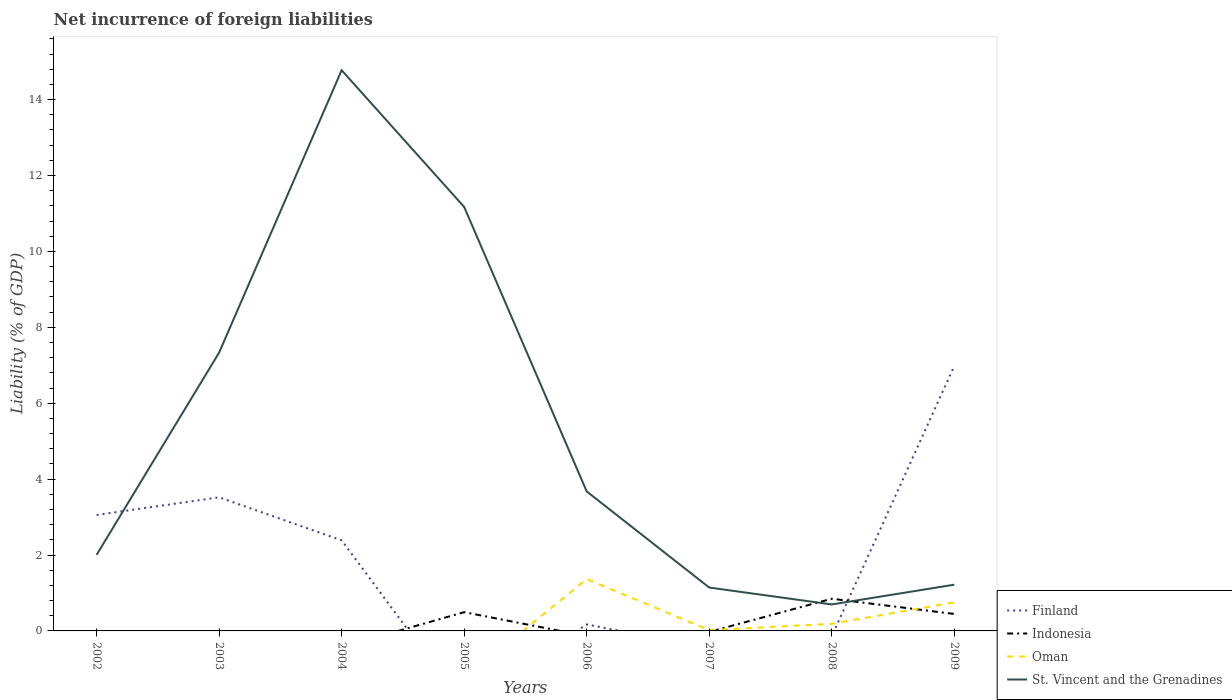Does the line corresponding to Indonesia intersect with the line corresponding to Oman?
Your answer should be very brief. Yes. Is the number of lines equal to the number of legend labels?
Your answer should be very brief. No. What is the total net incurrence of foreign liabilities in St. Vincent and the Grenadines in the graph?
Give a very brief answer. -3.84. What is the difference between the highest and the second highest net incurrence of foreign liabilities in St. Vincent and the Grenadines?
Keep it short and to the point. 14.08. What is the difference between the highest and the lowest net incurrence of foreign liabilities in St. Vincent and the Grenadines?
Your response must be concise. 3. Is the net incurrence of foreign liabilities in Indonesia strictly greater than the net incurrence of foreign liabilities in St. Vincent and the Grenadines over the years?
Ensure brevity in your answer.  No. How many lines are there?
Give a very brief answer. 4. How many years are there in the graph?
Keep it short and to the point. 8. What is the difference between two consecutive major ticks on the Y-axis?
Ensure brevity in your answer.  2. Are the values on the major ticks of Y-axis written in scientific E-notation?
Your answer should be very brief. No. Does the graph contain any zero values?
Offer a terse response. Yes. How many legend labels are there?
Your answer should be very brief. 4. What is the title of the graph?
Ensure brevity in your answer.  Net incurrence of foreign liabilities. What is the label or title of the X-axis?
Provide a succinct answer. Years. What is the label or title of the Y-axis?
Your answer should be compact. Liability (% of GDP). What is the Liability (% of GDP) of Finland in 2002?
Your response must be concise. 3.05. What is the Liability (% of GDP) of Indonesia in 2002?
Your answer should be very brief. 0. What is the Liability (% of GDP) in Oman in 2002?
Ensure brevity in your answer.  0. What is the Liability (% of GDP) in St. Vincent and the Grenadines in 2002?
Your answer should be very brief. 2. What is the Liability (% of GDP) of Finland in 2003?
Offer a terse response. 3.52. What is the Liability (% of GDP) in Indonesia in 2003?
Offer a terse response. 0. What is the Liability (% of GDP) of St. Vincent and the Grenadines in 2003?
Your response must be concise. 7.33. What is the Liability (% of GDP) of Finland in 2004?
Make the answer very short. 2.39. What is the Liability (% of GDP) of Indonesia in 2004?
Give a very brief answer. 0. What is the Liability (% of GDP) of St. Vincent and the Grenadines in 2004?
Ensure brevity in your answer.  14.77. What is the Liability (% of GDP) of Indonesia in 2005?
Provide a succinct answer. 0.49. What is the Liability (% of GDP) of St. Vincent and the Grenadines in 2005?
Your answer should be compact. 11.17. What is the Liability (% of GDP) in Finland in 2006?
Provide a short and direct response. 0.17. What is the Liability (% of GDP) of Indonesia in 2006?
Give a very brief answer. 0. What is the Liability (% of GDP) in Oman in 2006?
Offer a terse response. 1.37. What is the Liability (% of GDP) in St. Vincent and the Grenadines in 2006?
Your answer should be very brief. 3.67. What is the Liability (% of GDP) in Finland in 2007?
Offer a very short reply. 0. What is the Liability (% of GDP) of Oman in 2007?
Your answer should be very brief. 0.02. What is the Liability (% of GDP) of St. Vincent and the Grenadines in 2007?
Offer a terse response. 1.14. What is the Liability (% of GDP) in Finland in 2008?
Offer a terse response. 0. What is the Liability (% of GDP) of Indonesia in 2008?
Your response must be concise. 0.85. What is the Liability (% of GDP) of Oman in 2008?
Keep it short and to the point. 0.19. What is the Liability (% of GDP) of St. Vincent and the Grenadines in 2008?
Offer a very short reply. 0.7. What is the Liability (% of GDP) of Finland in 2009?
Give a very brief answer. 6.98. What is the Liability (% of GDP) in Indonesia in 2009?
Your response must be concise. 0.45. What is the Liability (% of GDP) in Oman in 2009?
Keep it short and to the point. 0.75. What is the Liability (% of GDP) of St. Vincent and the Grenadines in 2009?
Your answer should be very brief. 1.22. Across all years, what is the maximum Liability (% of GDP) of Finland?
Make the answer very short. 6.98. Across all years, what is the maximum Liability (% of GDP) in Indonesia?
Ensure brevity in your answer.  0.85. Across all years, what is the maximum Liability (% of GDP) of Oman?
Provide a succinct answer. 1.37. Across all years, what is the maximum Liability (% of GDP) of St. Vincent and the Grenadines?
Provide a succinct answer. 14.77. Across all years, what is the minimum Liability (% of GDP) in Finland?
Provide a short and direct response. 0. Across all years, what is the minimum Liability (% of GDP) in Indonesia?
Your answer should be very brief. 0. Across all years, what is the minimum Liability (% of GDP) of St. Vincent and the Grenadines?
Give a very brief answer. 0.7. What is the total Liability (% of GDP) of Finland in the graph?
Your answer should be compact. 16.11. What is the total Liability (% of GDP) in Indonesia in the graph?
Keep it short and to the point. 1.79. What is the total Liability (% of GDP) of Oman in the graph?
Your answer should be compact. 2.33. What is the total Liability (% of GDP) of St. Vincent and the Grenadines in the graph?
Provide a succinct answer. 42.01. What is the difference between the Liability (% of GDP) of Finland in 2002 and that in 2003?
Make the answer very short. -0.47. What is the difference between the Liability (% of GDP) of St. Vincent and the Grenadines in 2002 and that in 2003?
Ensure brevity in your answer.  -5.33. What is the difference between the Liability (% of GDP) in Finland in 2002 and that in 2004?
Provide a short and direct response. 0.67. What is the difference between the Liability (% of GDP) in St. Vincent and the Grenadines in 2002 and that in 2004?
Offer a very short reply. -12.77. What is the difference between the Liability (% of GDP) in St. Vincent and the Grenadines in 2002 and that in 2005?
Your answer should be very brief. -9.17. What is the difference between the Liability (% of GDP) of Finland in 2002 and that in 2006?
Your response must be concise. 2.88. What is the difference between the Liability (% of GDP) of St. Vincent and the Grenadines in 2002 and that in 2006?
Your answer should be compact. -1.67. What is the difference between the Liability (% of GDP) of St. Vincent and the Grenadines in 2002 and that in 2007?
Your response must be concise. 0.86. What is the difference between the Liability (% of GDP) in St. Vincent and the Grenadines in 2002 and that in 2008?
Give a very brief answer. 1.31. What is the difference between the Liability (% of GDP) in Finland in 2002 and that in 2009?
Your answer should be compact. -3.93. What is the difference between the Liability (% of GDP) of St. Vincent and the Grenadines in 2002 and that in 2009?
Make the answer very short. 0.79. What is the difference between the Liability (% of GDP) of Finland in 2003 and that in 2004?
Make the answer very short. 1.13. What is the difference between the Liability (% of GDP) in St. Vincent and the Grenadines in 2003 and that in 2004?
Make the answer very short. -7.44. What is the difference between the Liability (% of GDP) of St. Vincent and the Grenadines in 2003 and that in 2005?
Ensure brevity in your answer.  -3.84. What is the difference between the Liability (% of GDP) of Finland in 2003 and that in 2006?
Your answer should be compact. 3.35. What is the difference between the Liability (% of GDP) of St. Vincent and the Grenadines in 2003 and that in 2006?
Make the answer very short. 3.66. What is the difference between the Liability (% of GDP) in St. Vincent and the Grenadines in 2003 and that in 2007?
Offer a terse response. 6.19. What is the difference between the Liability (% of GDP) of St. Vincent and the Grenadines in 2003 and that in 2008?
Keep it short and to the point. 6.64. What is the difference between the Liability (% of GDP) in Finland in 2003 and that in 2009?
Provide a short and direct response. -3.46. What is the difference between the Liability (% of GDP) in St. Vincent and the Grenadines in 2003 and that in 2009?
Give a very brief answer. 6.12. What is the difference between the Liability (% of GDP) of St. Vincent and the Grenadines in 2004 and that in 2005?
Ensure brevity in your answer.  3.6. What is the difference between the Liability (% of GDP) of Finland in 2004 and that in 2006?
Offer a very short reply. 2.22. What is the difference between the Liability (% of GDP) in St. Vincent and the Grenadines in 2004 and that in 2006?
Offer a terse response. 11.1. What is the difference between the Liability (% of GDP) in St. Vincent and the Grenadines in 2004 and that in 2007?
Keep it short and to the point. 13.63. What is the difference between the Liability (% of GDP) of St. Vincent and the Grenadines in 2004 and that in 2008?
Give a very brief answer. 14.08. What is the difference between the Liability (% of GDP) of Finland in 2004 and that in 2009?
Give a very brief answer. -4.59. What is the difference between the Liability (% of GDP) of St. Vincent and the Grenadines in 2004 and that in 2009?
Your response must be concise. 13.55. What is the difference between the Liability (% of GDP) in St. Vincent and the Grenadines in 2005 and that in 2006?
Provide a short and direct response. 7.5. What is the difference between the Liability (% of GDP) of St. Vincent and the Grenadines in 2005 and that in 2007?
Your answer should be very brief. 10.03. What is the difference between the Liability (% of GDP) of Indonesia in 2005 and that in 2008?
Give a very brief answer. -0.35. What is the difference between the Liability (% of GDP) of St. Vincent and the Grenadines in 2005 and that in 2008?
Make the answer very short. 10.47. What is the difference between the Liability (% of GDP) of Indonesia in 2005 and that in 2009?
Make the answer very short. 0.05. What is the difference between the Liability (% of GDP) in St. Vincent and the Grenadines in 2005 and that in 2009?
Make the answer very short. 9.95. What is the difference between the Liability (% of GDP) of Oman in 2006 and that in 2007?
Provide a short and direct response. 1.35. What is the difference between the Liability (% of GDP) of St. Vincent and the Grenadines in 2006 and that in 2007?
Offer a terse response. 2.53. What is the difference between the Liability (% of GDP) of Oman in 2006 and that in 2008?
Offer a terse response. 1.18. What is the difference between the Liability (% of GDP) of St. Vincent and the Grenadines in 2006 and that in 2008?
Make the answer very short. 2.98. What is the difference between the Liability (% of GDP) in Finland in 2006 and that in 2009?
Offer a very short reply. -6.81. What is the difference between the Liability (% of GDP) in Oman in 2006 and that in 2009?
Make the answer very short. 0.61. What is the difference between the Liability (% of GDP) in St. Vincent and the Grenadines in 2006 and that in 2009?
Your answer should be compact. 2.46. What is the difference between the Liability (% of GDP) of Oman in 2007 and that in 2008?
Your answer should be compact. -0.17. What is the difference between the Liability (% of GDP) of St. Vincent and the Grenadines in 2007 and that in 2008?
Provide a short and direct response. 0.45. What is the difference between the Liability (% of GDP) in Oman in 2007 and that in 2009?
Your answer should be compact. -0.73. What is the difference between the Liability (% of GDP) of St. Vincent and the Grenadines in 2007 and that in 2009?
Provide a succinct answer. -0.08. What is the difference between the Liability (% of GDP) of Indonesia in 2008 and that in 2009?
Your answer should be very brief. 0.4. What is the difference between the Liability (% of GDP) in Oman in 2008 and that in 2009?
Offer a very short reply. -0.56. What is the difference between the Liability (% of GDP) of St. Vincent and the Grenadines in 2008 and that in 2009?
Offer a terse response. -0.52. What is the difference between the Liability (% of GDP) of Finland in 2002 and the Liability (% of GDP) of St. Vincent and the Grenadines in 2003?
Keep it short and to the point. -4.28. What is the difference between the Liability (% of GDP) in Finland in 2002 and the Liability (% of GDP) in St. Vincent and the Grenadines in 2004?
Offer a terse response. -11.72. What is the difference between the Liability (% of GDP) of Finland in 2002 and the Liability (% of GDP) of Indonesia in 2005?
Provide a short and direct response. 2.56. What is the difference between the Liability (% of GDP) of Finland in 2002 and the Liability (% of GDP) of St. Vincent and the Grenadines in 2005?
Your answer should be very brief. -8.12. What is the difference between the Liability (% of GDP) of Finland in 2002 and the Liability (% of GDP) of Oman in 2006?
Provide a succinct answer. 1.69. What is the difference between the Liability (% of GDP) in Finland in 2002 and the Liability (% of GDP) in St. Vincent and the Grenadines in 2006?
Your answer should be very brief. -0.62. What is the difference between the Liability (% of GDP) in Finland in 2002 and the Liability (% of GDP) in Oman in 2007?
Ensure brevity in your answer.  3.04. What is the difference between the Liability (% of GDP) of Finland in 2002 and the Liability (% of GDP) of St. Vincent and the Grenadines in 2007?
Ensure brevity in your answer.  1.91. What is the difference between the Liability (% of GDP) in Finland in 2002 and the Liability (% of GDP) in Indonesia in 2008?
Your answer should be compact. 2.21. What is the difference between the Liability (% of GDP) of Finland in 2002 and the Liability (% of GDP) of Oman in 2008?
Ensure brevity in your answer.  2.87. What is the difference between the Liability (% of GDP) of Finland in 2002 and the Liability (% of GDP) of St. Vincent and the Grenadines in 2008?
Keep it short and to the point. 2.36. What is the difference between the Liability (% of GDP) in Finland in 2002 and the Liability (% of GDP) in Indonesia in 2009?
Offer a terse response. 2.61. What is the difference between the Liability (% of GDP) in Finland in 2002 and the Liability (% of GDP) in Oman in 2009?
Give a very brief answer. 2.3. What is the difference between the Liability (% of GDP) of Finland in 2002 and the Liability (% of GDP) of St. Vincent and the Grenadines in 2009?
Make the answer very short. 1.84. What is the difference between the Liability (% of GDP) in Finland in 2003 and the Liability (% of GDP) in St. Vincent and the Grenadines in 2004?
Offer a terse response. -11.25. What is the difference between the Liability (% of GDP) of Finland in 2003 and the Liability (% of GDP) of Indonesia in 2005?
Provide a succinct answer. 3.03. What is the difference between the Liability (% of GDP) of Finland in 2003 and the Liability (% of GDP) of St. Vincent and the Grenadines in 2005?
Give a very brief answer. -7.65. What is the difference between the Liability (% of GDP) in Finland in 2003 and the Liability (% of GDP) in Oman in 2006?
Your response must be concise. 2.15. What is the difference between the Liability (% of GDP) in Finland in 2003 and the Liability (% of GDP) in St. Vincent and the Grenadines in 2006?
Keep it short and to the point. -0.15. What is the difference between the Liability (% of GDP) in Finland in 2003 and the Liability (% of GDP) in Oman in 2007?
Provide a short and direct response. 3.5. What is the difference between the Liability (% of GDP) of Finland in 2003 and the Liability (% of GDP) of St. Vincent and the Grenadines in 2007?
Give a very brief answer. 2.38. What is the difference between the Liability (% of GDP) in Finland in 2003 and the Liability (% of GDP) in Indonesia in 2008?
Offer a very short reply. 2.67. What is the difference between the Liability (% of GDP) in Finland in 2003 and the Liability (% of GDP) in Oman in 2008?
Provide a short and direct response. 3.33. What is the difference between the Liability (% of GDP) in Finland in 2003 and the Liability (% of GDP) in St. Vincent and the Grenadines in 2008?
Offer a very short reply. 2.82. What is the difference between the Liability (% of GDP) of Finland in 2003 and the Liability (% of GDP) of Indonesia in 2009?
Your answer should be very brief. 3.07. What is the difference between the Liability (% of GDP) in Finland in 2003 and the Liability (% of GDP) in Oman in 2009?
Your answer should be compact. 2.77. What is the difference between the Liability (% of GDP) of Finland in 2003 and the Liability (% of GDP) of St. Vincent and the Grenadines in 2009?
Your response must be concise. 2.3. What is the difference between the Liability (% of GDP) of Finland in 2004 and the Liability (% of GDP) of Indonesia in 2005?
Provide a succinct answer. 1.89. What is the difference between the Liability (% of GDP) of Finland in 2004 and the Liability (% of GDP) of St. Vincent and the Grenadines in 2005?
Provide a succinct answer. -8.78. What is the difference between the Liability (% of GDP) in Finland in 2004 and the Liability (% of GDP) in Oman in 2006?
Provide a succinct answer. 1.02. What is the difference between the Liability (% of GDP) of Finland in 2004 and the Liability (% of GDP) of St. Vincent and the Grenadines in 2006?
Offer a terse response. -1.29. What is the difference between the Liability (% of GDP) in Finland in 2004 and the Liability (% of GDP) in Oman in 2007?
Offer a very short reply. 2.37. What is the difference between the Liability (% of GDP) in Finland in 2004 and the Liability (% of GDP) in St. Vincent and the Grenadines in 2007?
Give a very brief answer. 1.24. What is the difference between the Liability (% of GDP) of Finland in 2004 and the Liability (% of GDP) of Indonesia in 2008?
Keep it short and to the point. 1.54. What is the difference between the Liability (% of GDP) of Finland in 2004 and the Liability (% of GDP) of Oman in 2008?
Your answer should be very brief. 2.2. What is the difference between the Liability (% of GDP) in Finland in 2004 and the Liability (% of GDP) in St. Vincent and the Grenadines in 2008?
Make the answer very short. 1.69. What is the difference between the Liability (% of GDP) of Finland in 2004 and the Liability (% of GDP) of Indonesia in 2009?
Provide a short and direct response. 1.94. What is the difference between the Liability (% of GDP) in Finland in 2004 and the Liability (% of GDP) in Oman in 2009?
Give a very brief answer. 1.63. What is the difference between the Liability (% of GDP) of Finland in 2004 and the Liability (% of GDP) of St. Vincent and the Grenadines in 2009?
Ensure brevity in your answer.  1.17. What is the difference between the Liability (% of GDP) of Indonesia in 2005 and the Liability (% of GDP) of Oman in 2006?
Your answer should be compact. -0.87. What is the difference between the Liability (% of GDP) of Indonesia in 2005 and the Liability (% of GDP) of St. Vincent and the Grenadines in 2006?
Offer a terse response. -3.18. What is the difference between the Liability (% of GDP) in Indonesia in 2005 and the Liability (% of GDP) in Oman in 2007?
Your answer should be compact. 0.47. What is the difference between the Liability (% of GDP) in Indonesia in 2005 and the Liability (% of GDP) in St. Vincent and the Grenadines in 2007?
Provide a short and direct response. -0.65. What is the difference between the Liability (% of GDP) of Indonesia in 2005 and the Liability (% of GDP) of Oman in 2008?
Give a very brief answer. 0.31. What is the difference between the Liability (% of GDP) of Indonesia in 2005 and the Liability (% of GDP) of St. Vincent and the Grenadines in 2008?
Provide a succinct answer. -0.2. What is the difference between the Liability (% of GDP) of Indonesia in 2005 and the Liability (% of GDP) of Oman in 2009?
Your response must be concise. -0.26. What is the difference between the Liability (% of GDP) of Indonesia in 2005 and the Liability (% of GDP) of St. Vincent and the Grenadines in 2009?
Offer a terse response. -0.72. What is the difference between the Liability (% of GDP) of Finland in 2006 and the Liability (% of GDP) of Oman in 2007?
Offer a terse response. 0.15. What is the difference between the Liability (% of GDP) in Finland in 2006 and the Liability (% of GDP) in St. Vincent and the Grenadines in 2007?
Your answer should be very brief. -0.97. What is the difference between the Liability (% of GDP) in Oman in 2006 and the Liability (% of GDP) in St. Vincent and the Grenadines in 2007?
Ensure brevity in your answer.  0.22. What is the difference between the Liability (% of GDP) of Finland in 2006 and the Liability (% of GDP) of Indonesia in 2008?
Keep it short and to the point. -0.68. What is the difference between the Liability (% of GDP) of Finland in 2006 and the Liability (% of GDP) of Oman in 2008?
Your response must be concise. -0.02. What is the difference between the Liability (% of GDP) of Finland in 2006 and the Liability (% of GDP) of St. Vincent and the Grenadines in 2008?
Ensure brevity in your answer.  -0.53. What is the difference between the Liability (% of GDP) of Oman in 2006 and the Liability (% of GDP) of St. Vincent and the Grenadines in 2008?
Provide a short and direct response. 0.67. What is the difference between the Liability (% of GDP) in Finland in 2006 and the Liability (% of GDP) in Indonesia in 2009?
Offer a terse response. -0.28. What is the difference between the Liability (% of GDP) in Finland in 2006 and the Liability (% of GDP) in Oman in 2009?
Your response must be concise. -0.58. What is the difference between the Liability (% of GDP) of Finland in 2006 and the Liability (% of GDP) of St. Vincent and the Grenadines in 2009?
Provide a succinct answer. -1.05. What is the difference between the Liability (% of GDP) in Oman in 2006 and the Liability (% of GDP) in St. Vincent and the Grenadines in 2009?
Offer a terse response. 0.15. What is the difference between the Liability (% of GDP) of Oman in 2007 and the Liability (% of GDP) of St. Vincent and the Grenadines in 2008?
Offer a terse response. -0.68. What is the difference between the Liability (% of GDP) in Oman in 2007 and the Liability (% of GDP) in St. Vincent and the Grenadines in 2009?
Provide a succinct answer. -1.2. What is the difference between the Liability (% of GDP) in Indonesia in 2008 and the Liability (% of GDP) in Oman in 2009?
Your answer should be very brief. 0.1. What is the difference between the Liability (% of GDP) of Indonesia in 2008 and the Liability (% of GDP) of St. Vincent and the Grenadines in 2009?
Keep it short and to the point. -0.37. What is the difference between the Liability (% of GDP) in Oman in 2008 and the Liability (% of GDP) in St. Vincent and the Grenadines in 2009?
Offer a terse response. -1.03. What is the average Liability (% of GDP) of Finland per year?
Ensure brevity in your answer.  2.01. What is the average Liability (% of GDP) of Indonesia per year?
Give a very brief answer. 0.22. What is the average Liability (% of GDP) of Oman per year?
Keep it short and to the point. 0.29. What is the average Liability (% of GDP) of St. Vincent and the Grenadines per year?
Your answer should be very brief. 5.25. In the year 2002, what is the difference between the Liability (% of GDP) in Finland and Liability (% of GDP) in St. Vincent and the Grenadines?
Make the answer very short. 1.05. In the year 2003, what is the difference between the Liability (% of GDP) of Finland and Liability (% of GDP) of St. Vincent and the Grenadines?
Keep it short and to the point. -3.81. In the year 2004, what is the difference between the Liability (% of GDP) of Finland and Liability (% of GDP) of St. Vincent and the Grenadines?
Provide a short and direct response. -12.39. In the year 2005, what is the difference between the Liability (% of GDP) in Indonesia and Liability (% of GDP) in St. Vincent and the Grenadines?
Give a very brief answer. -10.68. In the year 2006, what is the difference between the Liability (% of GDP) in Finland and Liability (% of GDP) in Oman?
Make the answer very short. -1.19. In the year 2006, what is the difference between the Liability (% of GDP) of Finland and Liability (% of GDP) of St. Vincent and the Grenadines?
Provide a succinct answer. -3.5. In the year 2006, what is the difference between the Liability (% of GDP) of Oman and Liability (% of GDP) of St. Vincent and the Grenadines?
Your answer should be compact. -2.31. In the year 2007, what is the difference between the Liability (% of GDP) in Oman and Liability (% of GDP) in St. Vincent and the Grenadines?
Keep it short and to the point. -1.12. In the year 2008, what is the difference between the Liability (% of GDP) in Indonesia and Liability (% of GDP) in Oman?
Provide a short and direct response. 0.66. In the year 2008, what is the difference between the Liability (% of GDP) in Indonesia and Liability (% of GDP) in St. Vincent and the Grenadines?
Offer a terse response. 0.15. In the year 2008, what is the difference between the Liability (% of GDP) of Oman and Liability (% of GDP) of St. Vincent and the Grenadines?
Your answer should be compact. -0.51. In the year 2009, what is the difference between the Liability (% of GDP) of Finland and Liability (% of GDP) of Indonesia?
Give a very brief answer. 6.53. In the year 2009, what is the difference between the Liability (% of GDP) in Finland and Liability (% of GDP) in Oman?
Make the answer very short. 6.23. In the year 2009, what is the difference between the Liability (% of GDP) of Finland and Liability (% of GDP) of St. Vincent and the Grenadines?
Your response must be concise. 5.76. In the year 2009, what is the difference between the Liability (% of GDP) in Indonesia and Liability (% of GDP) in Oman?
Offer a terse response. -0.31. In the year 2009, what is the difference between the Liability (% of GDP) in Indonesia and Liability (% of GDP) in St. Vincent and the Grenadines?
Provide a succinct answer. -0.77. In the year 2009, what is the difference between the Liability (% of GDP) of Oman and Liability (% of GDP) of St. Vincent and the Grenadines?
Provide a succinct answer. -0.47. What is the ratio of the Liability (% of GDP) in Finland in 2002 to that in 2003?
Offer a very short reply. 0.87. What is the ratio of the Liability (% of GDP) in St. Vincent and the Grenadines in 2002 to that in 2003?
Your response must be concise. 0.27. What is the ratio of the Liability (% of GDP) in Finland in 2002 to that in 2004?
Make the answer very short. 1.28. What is the ratio of the Liability (% of GDP) in St. Vincent and the Grenadines in 2002 to that in 2004?
Make the answer very short. 0.14. What is the ratio of the Liability (% of GDP) of St. Vincent and the Grenadines in 2002 to that in 2005?
Your answer should be very brief. 0.18. What is the ratio of the Liability (% of GDP) in Finland in 2002 to that in 2006?
Offer a very short reply. 17.81. What is the ratio of the Liability (% of GDP) in St. Vincent and the Grenadines in 2002 to that in 2006?
Give a very brief answer. 0.55. What is the ratio of the Liability (% of GDP) of St. Vincent and the Grenadines in 2002 to that in 2007?
Offer a very short reply. 1.75. What is the ratio of the Liability (% of GDP) in St. Vincent and the Grenadines in 2002 to that in 2008?
Give a very brief answer. 2.87. What is the ratio of the Liability (% of GDP) in Finland in 2002 to that in 2009?
Provide a short and direct response. 0.44. What is the ratio of the Liability (% of GDP) of St. Vincent and the Grenadines in 2002 to that in 2009?
Give a very brief answer. 1.65. What is the ratio of the Liability (% of GDP) of Finland in 2003 to that in 2004?
Your response must be concise. 1.47. What is the ratio of the Liability (% of GDP) in St. Vincent and the Grenadines in 2003 to that in 2004?
Provide a succinct answer. 0.5. What is the ratio of the Liability (% of GDP) in St. Vincent and the Grenadines in 2003 to that in 2005?
Your answer should be compact. 0.66. What is the ratio of the Liability (% of GDP) in Finland in 2003 to that in 2006?
Offer a terse response. 20.53. What is the ratio of the Liability (% of GDP) of St. Vincent and the Grenadines in 2003 to that in 2006?
Provide a short and direct response. 2. What is the ratio of the Liability (% of GDP) in St. Vincent and the Grenadines in 2003 to that in 2007?
Provide a short and direct response. 6.42. What is the ratio of the Liability (% of GDP) in St. Vincent and the Grenadines in 2003 to that in 2008?
Ensure brevity in your answer.  10.51. What is the ratio of the Liability (% of GDP) of Finland in 2003 to that in 2009?
Offer a terse response. 0.5. What is the ratio of the Liability (% of GDP) in St. Vincent and the Grenadines in 2003 to that in 2009?
Ensure brevity in your answer.  6.02. What is the ratio of the Liability (% of GDP) of St. Vincent and the Grenadines in 2004 to that in 2005?
Keep it short and to the point. 1.32. What is the ratio of the Liability (% of GDP) in Finland in 2004 to that in 2006?
Make the answer very short. 13.92. What is the ratio of the Liability (% of GDP) of St. Vincent and the Grenadines in 2004 to that in 2006?
Provide a short and direct response. 4.02. What is the ratio of the Liability (% of GDP) of St. Vincent and the Grenadines in 2004 to that in 2007?
Make the answer very short. 12.93. What is the ratio of the Liability (% of GDP) in St. Vincent and the Grenadines in 2004 to that in 2008?
Provide a succinct answer. 21.17. What is the ratio of the Liability (% of GDP) in Finland in 2004 to that in 2009?
Provide a short and direct response. 0.34. What is the ratio of the Liability (% of GDP) of St. Vincent and the Grenadines in 2004 to that in 2009?
Your response must be concise. 12.13. What is the ratio of the Liability (% of GDP) in St. Vincent and the Grenadines in 2005 to that in 2006?
Offer a terse response. 3.04. What is the ratio of the Liability (% of GDP) of St. Vincent and the Grenadines in 2005 to that in 2007?
Your answer should be compact. 9.77. What is the ratio of the Liability (% of GDP) of Indonesia in 2005 to that in 2008?
Make the answer very short. 0.58. What is the ratio of the Liability (% of GDP) of St. Vincent and the Grenadines in 2005 to that in 2008?
Your response must be concise. 16.01. What is the ratio of the Liability (% of GDP) in Indonesia in 2005 to that in 2009?
Make the answer very short. 1.1. What is the ratio of the Liability (% of GDP) of St. Vincent and the Grenadines in 2005 to that in 2009?
Give a very brief answer. 9.17. What is the ratio of the Liability (% of GDP) in Oman in 2006 to that in 2007?
Your answer should be very brief. 69.09. What is the ratio of the Liability (% of GDP) in St. Vincent and the Grenadines in 2006 to that in 2007?
Provide a short and direct response. 3.22. What is the ratio of the Liability (% of GDP) of Oman in 2006 to that in 2008?
Offer a very short reply. 7.27. What is the ratio of the Liability (% of GDP) in St. Vincent and the Grenadines in 2006 to that in 2008?
Make the answer very short. 5.27. What is the ratio of the Liability (% of GDP) of Finland in 2006 to that in 2009?
Offer a very short reply. 0.02. What is the ratio of the Liability (% of GDP) in Oman in 2006 to that in 2009?
Offer a terse response. 1.82. What is the ratio of the Liability (% of GDP) in St. Vincent and the Grenadines in 2006 to that in 2009?
Give a very brief answer. 3.02. What is the ratio of the Liability (% of GDP) of Oman in 2007 to that in 2008?
Provide a succinct answer. 0.11. What is the ratio of the Liability (% of GDP) in St. Vincent and the Grenadines in 2007 to that in 2008?
Give a very brief answer. 1.64. What is the ratio of the Liability (% of GDP) in Oman in 2007 to that in 2009?
Your answer should be very brief. 0.03. What is the ratio of the Liability (% of GDP) of St. Vincent and the Grenadines in 2007 to that in 2009?
Ensure brevity in your answer.  0.94. What is the ratio of the Liability (% of GDP) of Indonesia in 2008 to that in 2009?
Make the answer very short. 1.9. What is the ratio of the Liability (% of GDP) in Oman in 2008 to that in 2009?
Provide a short and direct response. 0.25. What is the ratio of the Liability (% of GDP) of St. Vincent and the Grenadines in 2008 to that in 2009?
Provide a succinct answer. 0.57. What is the difference between the highest and the second highest Liability (% of GDP) of Finland?
Ensure brevity in your answer.  3.46. What is the difference between the highest and the second highest Liability (% of GDP) in Indonesia?
Your answer should be compact. 0.35. What is the difference between the highest and the second highest Liability (% of GDP) of Oman?
Your answer should be compact. 0.61. What is the difference between the highest and the second highest Liability (% of GDP) in St. Vincent and the Grenadines?
Keep it short and to the point. 3.6. What is the difference between the highest and the lowest Liability (% of GDP) of Finland?
Your response must be concise. 6.98. What is the difference between the highest and the lowest Liability (% of GDP) of Indonesia?
Offer a very short reply. 0.85. What is the difference between the highest and the lowest Liability (% of GDP) of Oman?
Offer a very short reply. 1.37. What is the difference between the highest and the lowest Liability (% of GDP) in St. Vincent and the Grenadines?
Provide a short and direct response. 14.08. 